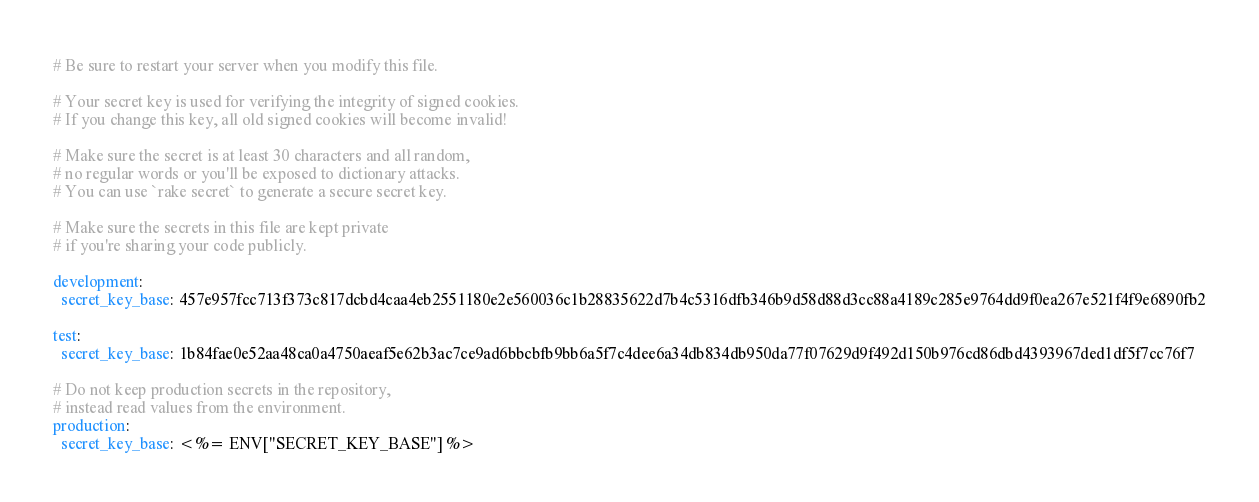<code> <loc_0><loc_0><loc_500><loc_500><_YAML_># Be sure to restart your server when you modify this file.

# Your secret key is used for verifying the integrity of signed cookies.
# If you change this key, all old signed cookies will become invalid!

# Make sure the secret is at least 30 characters and all random,
# no regular words or you'll be exposed to dictionary attacks.
# You can use `rake secret` to generate a secure secret key.

# Make sure the secrets in this file are kept private
# if you're sharing your code publicly.

development:
  secret_key_base: 457e957fcc713f373c817dcbd4caa4eb2551180e2e560036c1b28835622d7b4c5316dfb346b9d58d88d3cc88a4189c285e9764dd9f0ea267e521f4f9e6890fb2

test:
  secret_key_base: 1b84fae0e52aa48ca0a4750aeaf5e62b3ac7ce9ad6bbcbfb9bb6a5f7c4dee6a34db834db950da77f07629d9f492d150b976cd86dbd4393967ded1df5f7cc76f7

# Do not keep production secrets in the repository,
# instead read values from the environment.
production:
  secret_key_base: <%= ENV["SECRET_KEY_BASE"] %>
</code> 